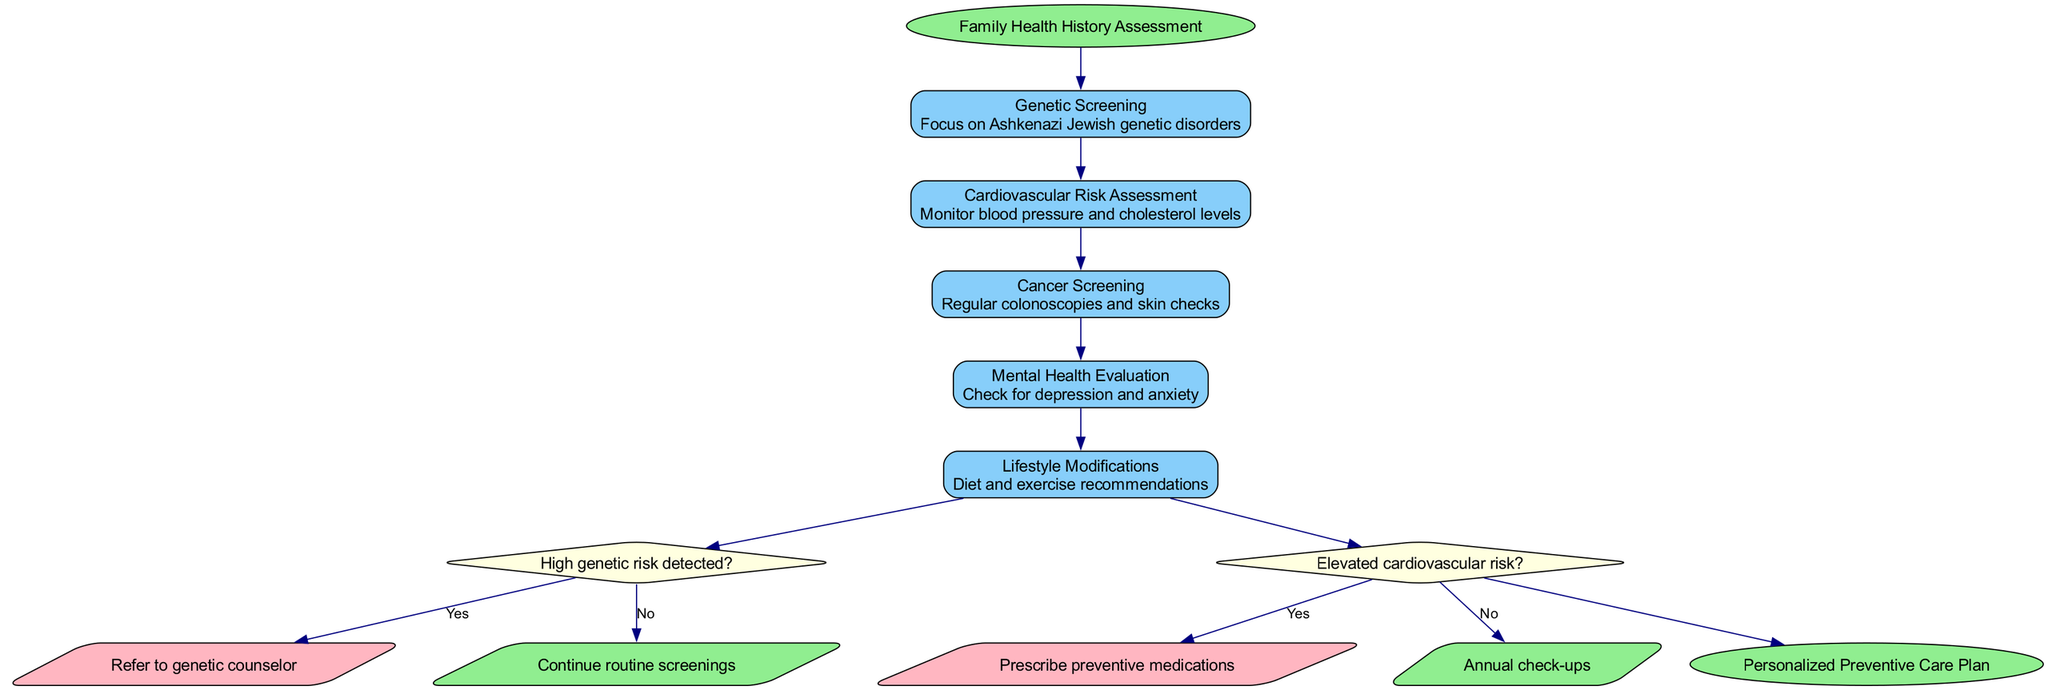What is the starting point of the clinical pathway? The starting point node in the diagram is labeled "Family Health History Assessment," which indicates the beginning of the pathway.
Answer: Family Health History Assessment How many steps are there in the pathway? Counting the nodes representing the steps, there are five steps outlined from Genetic Screening to Lifestyle Modifications.
Answer: 5 What follows the Mental Health Evaluation step? The diagram shows that after the Mental Health Evaluation, the next node is a decision point regarding high genetic risk.
Answer: Decision point What condition leads to a referral to a genetic counselor? The diagram specifies that if a high genetic risk is detected in the assessment, the pathway directs to a referral to a genetic counselor.
Answer: High genetic risk detected What happens if elevated cardiovascular risk is not detected? If there is no elevated cardiovascular risk, the pathway indicates that the individual should continue with annual check-ups.
Answer: Annual check-ups Which step includes recommendations for diet and exercise? The step focused on Lifestyle Modifications discusses the recommendations for diet and exercise within the preventive care plan.
Answer: Lifestyle Modifications What shapes are used for decision points in the diagram? The diagram uses diamond shapes to represent decision points, which indicates a conditional process in the clinical pathway.
Answer: Diamond shapes At which node do we achieve the end of the clinical pathway? The endpoint of the clinical pathway is represented by "Personalized Preventive Care Plan," indicating where the process concludes.
Answer: Personalized Preventive Care Plan What are the details included in the Cancer Screening step? The Cancer Screening step includes details of regular colonoscopies and skin checks as part of the preventive measures.
Answer: Regular colonoscopies and skin checks 